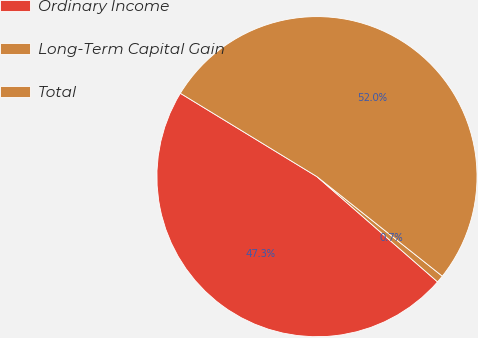Convert chart. <chart><loc_0><loc_0><loc_500><loc_500><pie_chart><fcel>Ordinary Income<fcel>Long-Term Capital Gain<fcel>Total<nl><fcel>47.3%<fcel>0.74%<fcel>51.96%<nl></chart> 